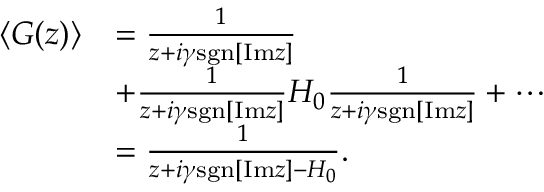Convert formula to latex. <formula><loc_0><loc_0><loc_500><loc_500>\begin{array} { r l } { \left < G ( z ) \right > } & { = \frac { 1 } { z + i \gamma s g n [ I m z ] } } \\ & { + \frac { 1 } { z + i \gamma s g n [ I m z ] } H _ { 0 } \frac { 1 } { z + i \gamma s g n [ I m z ] } + \cdots } \\ & { = \frac { 1 } { z + i \gamma s g n [ I m z ] - H _ { 0 } } . } \end{array}</formula> 